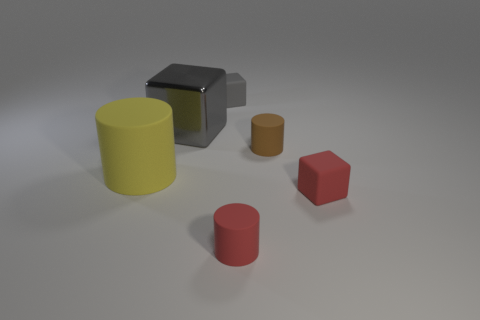Is the number of tiny brown rubber objects less than the number of tiny cylinders? yes 